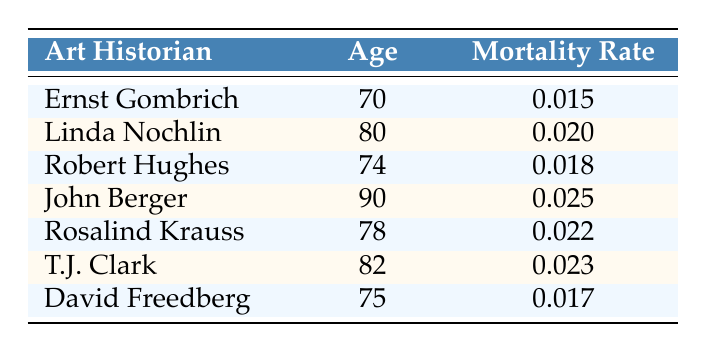What is the mortality rate for Ernst Gombrich? The table indicates Ernst Gombrich has a mortality rate of 0.015 at age 70.
Answer: 0.015 Which art historian is the oldest and what is their age? John Berger is the oldest art historian listed in the table at the age of 90.
Answer: John Berger, 90 What is the average mortality rate for the art historians aged 75 and above? The rates for those aged 75 and above are: David Freedberg (0.017), John Berger (0.025), and T.J. Clark (0.023). To find the average, sum these rates: 0.017 + 0.025 + 0.023 = 0.065, then divide by the number of historians (3), which yields 0.065/3 = 0.02167, rounding to 0.022.
Answer: 0.022 Is the mortality rate for Linda Nochlin higher than that of David Freedberg? Linda Nochlin has a mortality rate of 0.020, while David Freedberg has a rate of 0.017. Since 0.020 > 0.017, the statement is true.
Answer: Yes What is the total mortality rate of art historians aged 78 and younger? The ages and rates for those aged 78 and younger are: Ernst Gombrich (0.015), Robert Hughes (0.018), and David Freedberg (0.017), totaling 0.015 + 0.018 + 0.017 = 0.050.
Answer: 0.050 